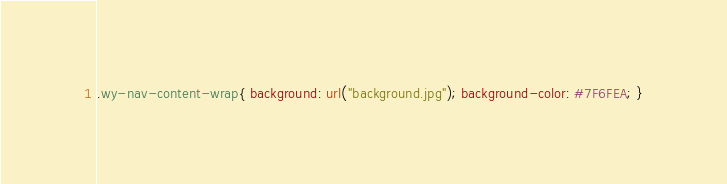Convert code to text. <code><loc_0><loc_0><loc_500><loc_500><_CSS_>.wy-nav-content-wrap{ background: url("background.jpg"); background-color: #7F6FEA; }</code> 